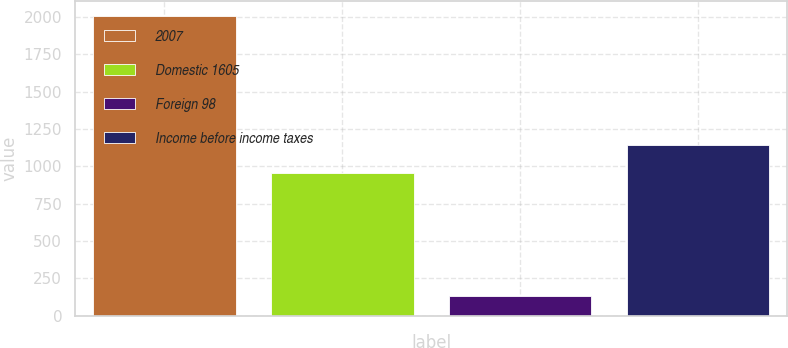Convert chart to OTSL. <chart><loc_0><loc_0><loc_500><loc_500><bar_chart><fcel>2007<fcel>Domestic 1605<fcel>Foreign 98<fcel>Income before income taxes<nl><fcel>2005<fcel>957<fcel>135<fcel>1144<nl></chart> 